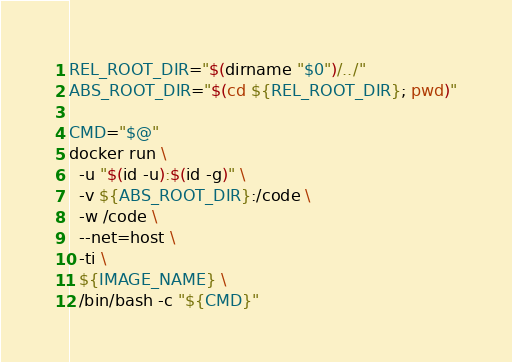Convert code to text. <code><loc_0><loc_0><loc_500><loc_500><_Bash_>REL_ROOT_DIR="$(dirname "$0")/../"
ABS_ROOT_DIR="$(cd ${REL_ROOT_DIR}; pwd)"

CMD="$@"
docker run \
  -u "$(id -u):$(id -g)" \
  -v ${ABS_ROOT_DIR}:/code \
  -w /code \
  --net=host \
  -ti \
  ${IMAGE_NAME} \
  /bin/bash -c "${CMD}"
</code> 